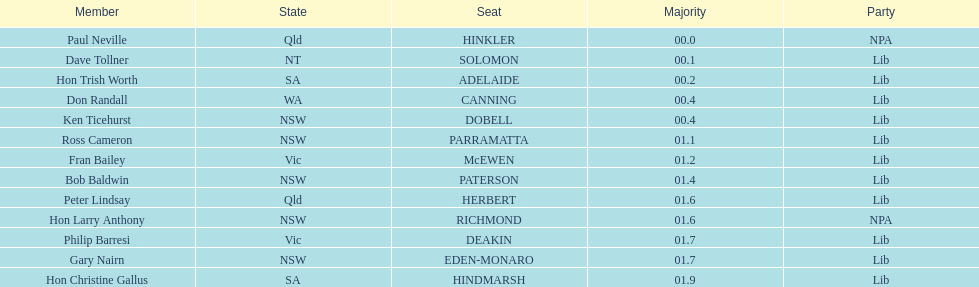Who is listed before don randall? Hon Trish Worth. 